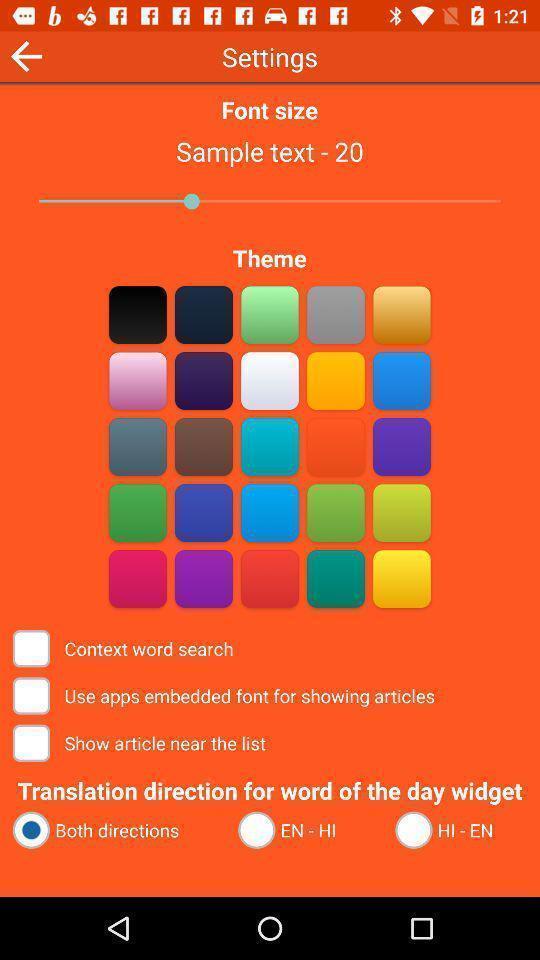Please provide a description for this image. Settings page. 